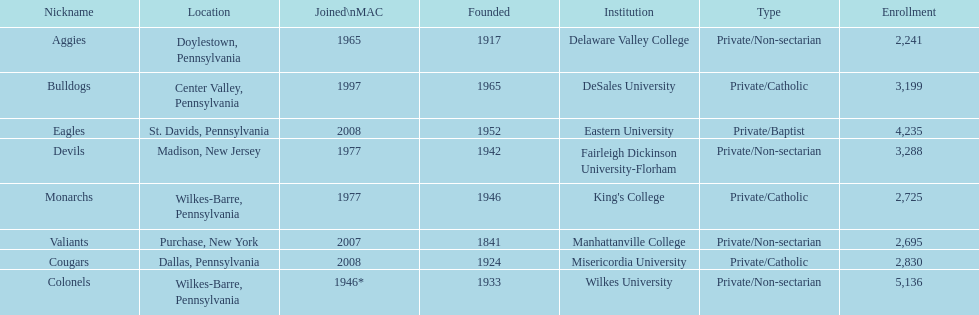What is the enrollment number of misericordia university? 2,830. 